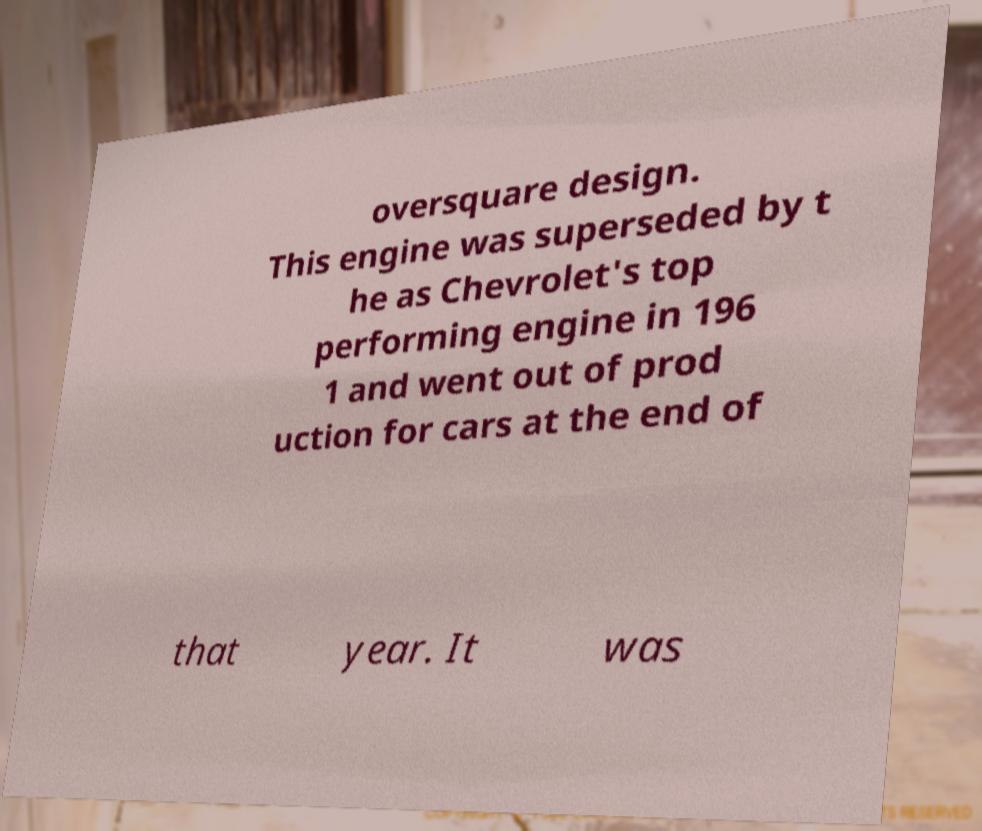There's text embedded in this image that I need extracted. Can you transcribe it verbatim? oversquare design. This engine was superseded by t he as Chevrolet's top performing engine in 196 1 and went out of prod uction for cars at the end of that year. It was 